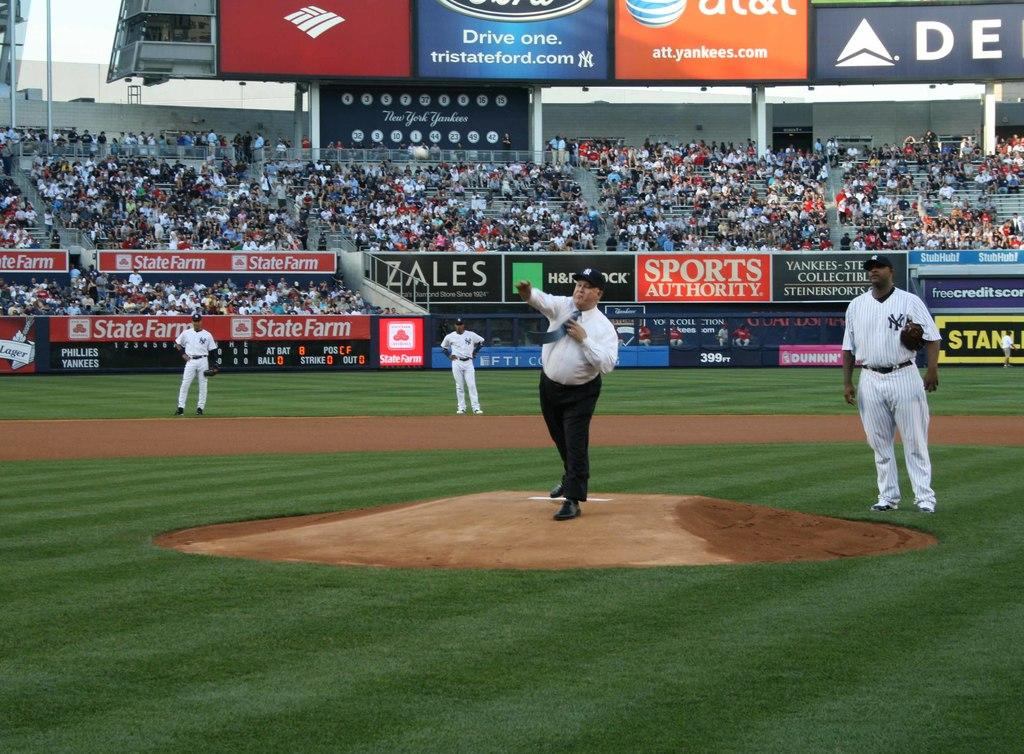<image>
Summarize the visual content of the image. A baseball stadium with an ad for Zales in the background. 